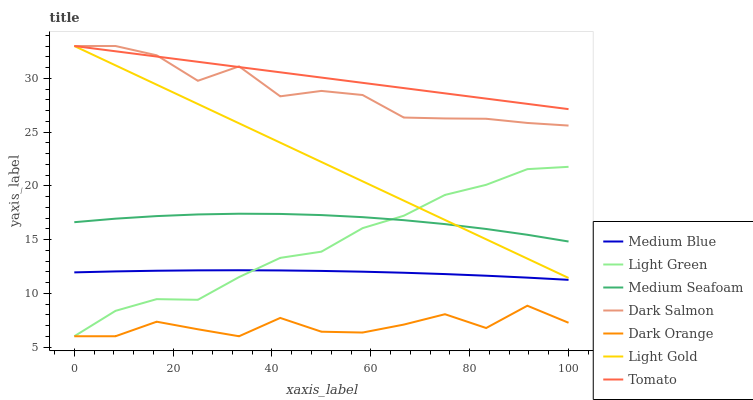Does Dark Orange have the minimum area under the curve?
Answer yes or no. Yes. Does Tomato have the maximum area under the curve?
Answer yes or no. Yes. Does Medium Blue have the minimum area under the curve?
Answer yes or no. No. Does Medium Blue have the maximum area under the curve?
Answer yes or no. No. Is Tomato the smoothest?
Answer yes or no. Yes. Is Dark Orange the roughest?
Answer yes or no. Yes. Is Medium Blue the smoothest?
Answer yes or no. No. Is Medium Blue the roughest?
Answer yes or no. No. Does Dark Orange have the lowest value?
Answer yes or no. Yes. Does Medium Blue have the lowest value?
Answer yes or no. No. Does Light Gold have the highest value?
Answer yes or no. Yes. Does Medium Blue have the highest value?
Answer yes or no. No. Is Medium Blue less than Light Gold?
Answer yes or no. Yes. Is Tomato greater than Medium Blue?
Answer yes or no. Yes. Does Tomato intersect Dark Salmon?
Answer yes or no. Yes. Is Tomato less than Dark Salmon?
Answer yes or no. No. Is Tomato greater than Dark Salmon?
Answer yes or no. No. Does Medium Blue intersect Light Gold?
Answer yes or no. No. 